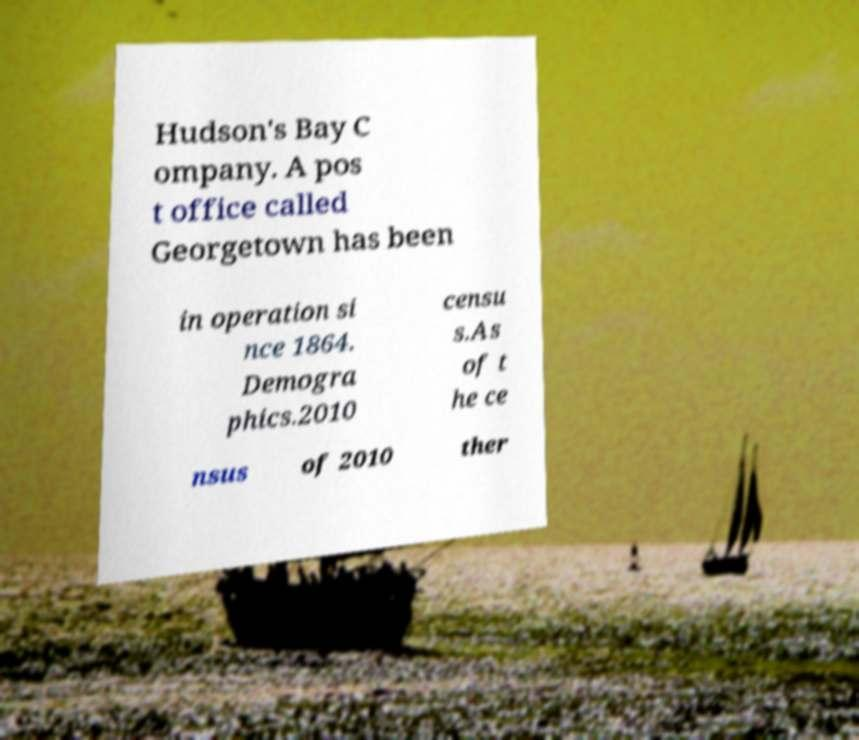What messages or text are displayed in this image? I need them in a readable, typed format. Hudson's Bay C ompany. A pos t office called Georgetown has been in operation si nce 1864. Demogra phics.2010 censu s.As of t he ce nsus of 2010 ther 